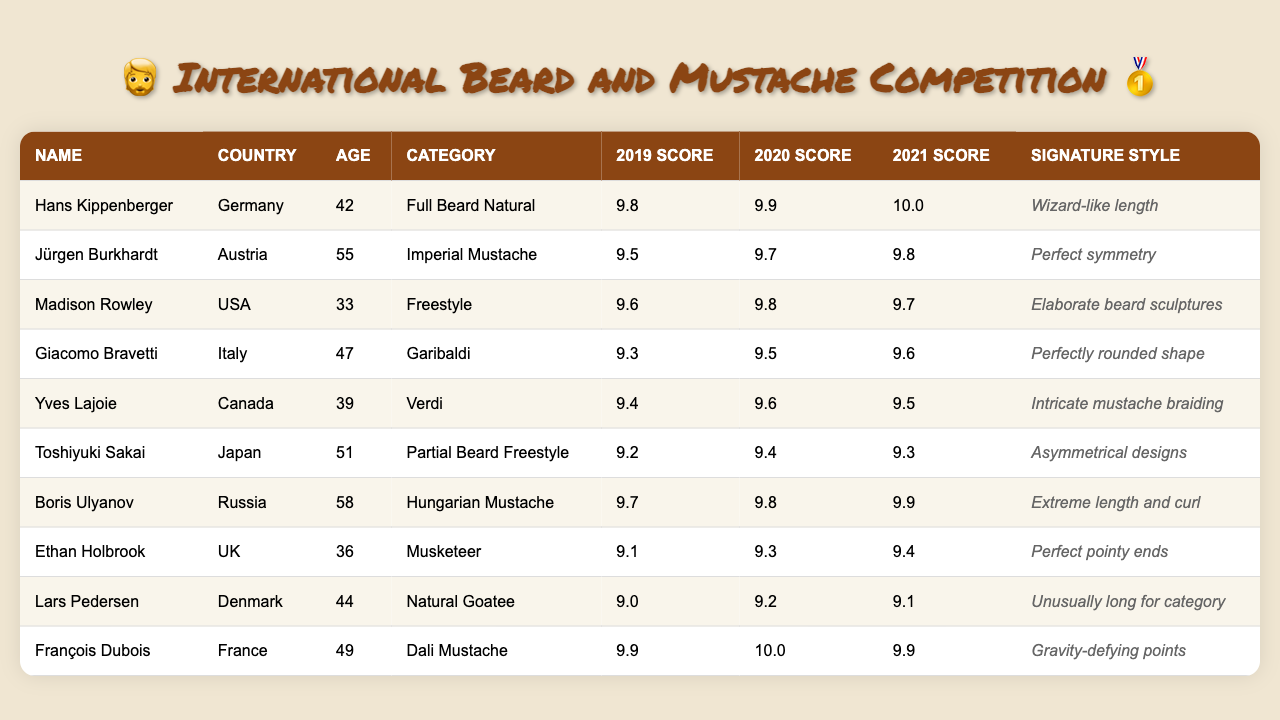What is the highest score achieved in 2021? The highest score in the 2021 column is 10.0, which was achieved by Hans Kippenberger and François Dubois.
Answer: 10.0 Which participant is from Japan? By looking at the country column, Toshiyuki Sakai is listed as the participant from Japan.
Answer: Toshiyuki Sakai What is the average score of Lars Pedersen over three years? Lars Pedersen's scores are 9.0, 9.2, and 9.1. To find the average, sum the scores: (9.0 + 9.2 + 9.1) = 27.3. Divide by 3 to get the average: 27.3 / 3 = 9.1.
Answer: 9.1 Which participant won the Imperial Mustache category? The participant with this category is Jürgen Burkhardt, as listed under the category column.
Answer: Jürgen Burkhardt Did any participant score above 9.5 in 2019? Checking the 2019 scores, two participants scored above 9.5: Hans Kippenberger (9.8) and François Dubois (9.9). Thus, the answer is yes.
Answer: Yes What is the difference between the highest and lowest scores for Boris Ulyanov? Boris Ulyanov's scores are 9.7, 9.8, and 9.9. The highest score is 9.9 and the lowest is 9.7. The difference is 9.9 - 9.7 = 0.2.
Answer: 0.2 Which category has the signature style of "Gravity-defying points"? The signature style "Gravity-defying points" belongs to François Dubois, who is listed under the Dali Mustache category.
Answer: Dali Mustache Is there any participant who improved their score from 2019 to 2021? By checking the scores for each participant from 2019 to 2021, the only one who improved is Hans Kippenberger, who went from 9.8 to 10.0.
Answer: Yes Which country has the participant with the signature style "Elaborate beard sculptures"? The participant with this signature style is Madison Rowley from the USA, as shown in the signature style column.
Answer: USA What is the median score in 2020? To find the median, first organize the 2020 scores: 9.3, 9.4, 9.5, 9.6, 9.7, 9.8, 9.9, 10.0. There are 8 scores, so the median is the average of the 4th and 5th scores: (9.6 + 9.7) / 2 = 9.65.
Answer: 9.65 